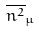<formula> <loc_0><loc_0><loc_500><loc_500>\overline { n ^ { 2 } } _ { \mu }</formula> 